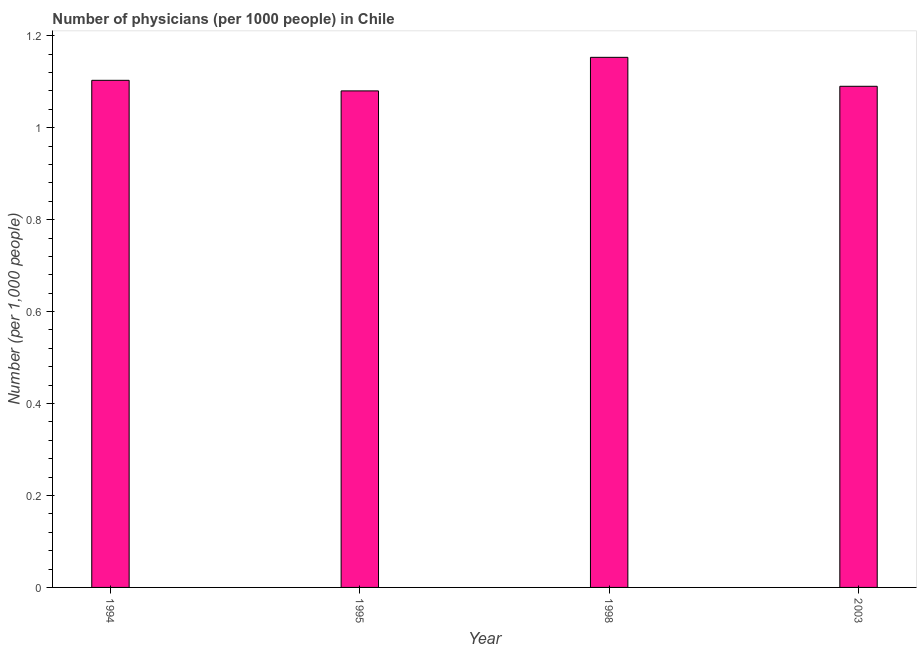Does the graph contain any zero values?
Provide a succinct answer. No. Does the graph contain grids?
Your answer should be compact. No. What is the title of the graph?
Ensure brevity in your answer.  Number of physicians (per 1000 people) in Chile. What is the label or title of the Y-axis?
Provide a short and direct response. Number (per 1,0 people). What is the number of physicians in 2003?
Offer a terse response. 1.09. Across all years, what is the maximum number of physicians?
Your answer should be very brief. 1.15. Across all years, what is the minimum number of physicians?
Your answer should be very brief. 1.08. In which year was the number of physicians maximum?
Make the answer very short. 1998. What is the sum of the number of physicians?
Provide a succinct answer. 4.43. What is the difference between the number of physicians in 1998 and 2003?
Make the answer very short. 0.06. What is the average number of physicians per year?
Provide a short and direct response. 1.11. What is the median number of physicians?
Ensure brevity in your answer.  1.1. Do a majority of the years between 2003 and 1998 (inclusive) have number of physicians greater than 0.24 ?
Offer a very short reply. No. What is the ratio of the number of physicians in 1998 to that in 2003?
Make the answer very short. 1.06. What is the difference between the highest and the second highest number of physicians?
Your answer should be compact. 0.05. Is the sum of the number of physicians in 1994 and 1995 greater than the maximum number of physicians across all years?
Keep it short and to the point. Yes. What is the difference between the highest and the lowest number of physicians?
Provide a short and direct response. 0.07. How many bars are there?
Offer a very short reply. 4. Are all the bars in the graph horizontal?
Make the answer very short. No. How many years are there in the graph?
Your response must be concise. 4. What is the difference between two consecutive major ticks on the Y-axis?
Your answer should be very brief. 0.2. Are the values on the major ticks of Y-axis written in scientific E-notation?
Your response must be concise. No. What is the Number (per 1,000 people) in 1994?
Offer a very short reply. 1.1. What is the Number (per 1,000 people) of 1995?
Give a very brief answer. 1.08. What is the Number (per 1,000 people) in 1998?
Ensure brevity in your answer.  1.15. What is the Number (per 1,000 people) in 2003?
Your answer should be compact. 1.09. What is the difference between the Number (per 1,000 people) in 1994 and 1995?
Keep it short and to the point. 0.02. What is the difference between the Number (per 1,000 people) in 1994 and 1998?
Offer a very short reply. -0.05. What is the difference between the Number (per 1,000 people) in 1994 and 2003?
Offer a very short reply. 0.01. What is the difference between the Number (per 1,000 people) in 1995 and 1998?
Make the answer very short. -0.07. What is the difference between the Number (per 1,000 people) in 1995 and 2003?
Provide a succinct answer. -0.01. What is the difference between the Number (per 1,000 people) in 1998 and 2003?
Keep it short and to the point. 0.06. What is the ratio of the Number (per 1,000 people) in 1995 to that in 1998?
Give a very brief answer. 0.94. What is the ratio of the Number (per 1,000 people) in 1995 to that in 2003?
Provide a succinct answer. 0.99. What is the ratio of the Number (per 1,000 people) in 1998 to that in 2003?
Offer a very short reply. 1.06. 